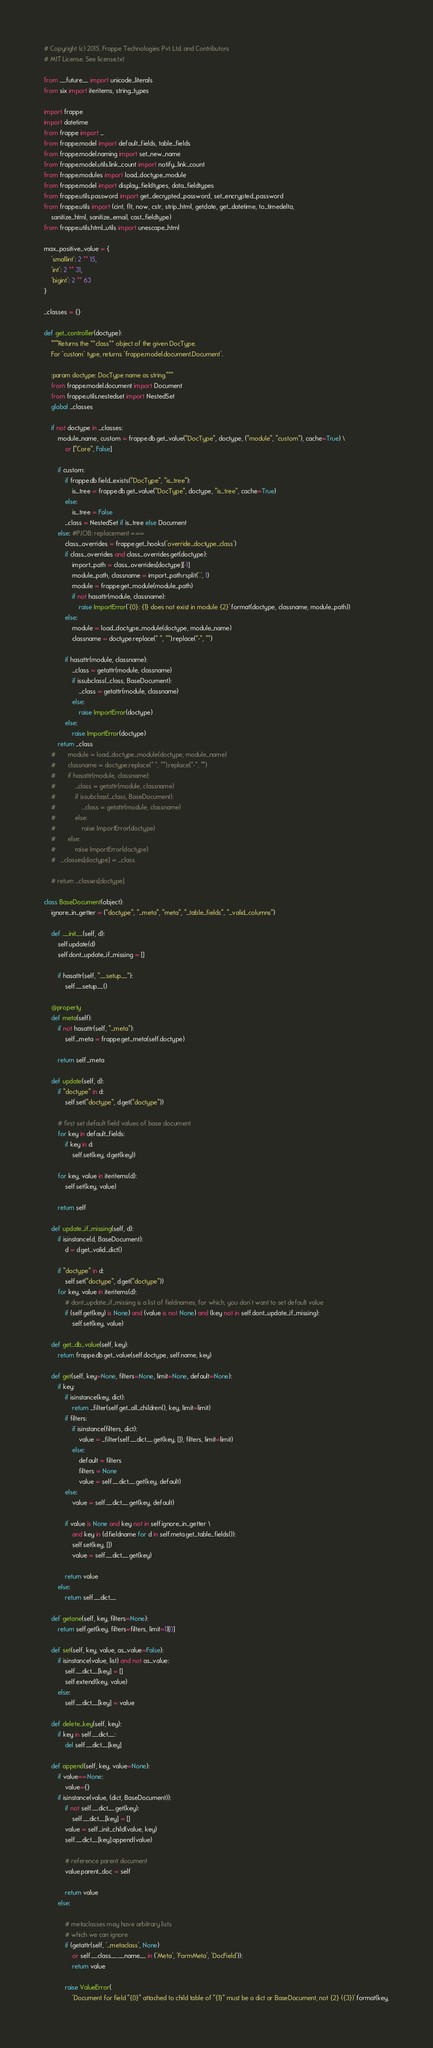<code> <loc_0><loc_0><loc_500><loc_500><_Python_># Copyright (c) 2015, Frappe Technologies Pvt. Ltd. and Contributors
# MIT License. See license.txt

from __future__ import unicode_literals
from six import iteritems, string_types

import frappe
import datetime
from frappe import _
from frappe.model import default_fields, table_fields
from frappe.model.naming import set_new_name
from frappe.model.utils.link_count import notify_link_count
from frappe.modules import load_doctype_module
from frappe.model import display_fieldtypes, data_fieldtypes
from frappe.utils.password import get_decrypted_password, set_encrypted_password
from frappe.utils import (cint, flt, now, cstr, strip_html, getdate, get_datetime, to_timedelta,
	sanitize_html, sanitize_email, cast_fieldtype)
from frappe.utils.html_utils import unescape_html

max_positive_value = {
	'smallint': 2 ** 15,
	'int': 2 ** 31,
	'bigint': 2 ** 63
}

_classes = {}

def get_controller(doctype):
	"""Returns the **class** object of the given DocType.
	For `custom` type, returns `frappe.model.document.Document`.

	:param doctype: DocType name as string."""
	from frappe.model.document import Document
	from frappe.utils.nestedset import NestedSet
	global _classes

	if not doctype in _classes:
		module_name, custom = frappe.db.get_value("DocType", doctype, ("module", "custom"), cache=True) \
			or ["Core", False]

		if custom:
			if frappe.db.field_exists("DocType", "is_tree"):
				is_tree = frappe.db.get_value("DocType", doctype, "is_tree", cache=True)
			else:
				is_tree = False
			_class = NestedSet if is_tree else Document
		else: #PJOB: replacement ===
			class_overrides = frappe.get_hooks('override_doctype_class')
			if class_overrides and class_overrides.get(doctype):
				import_path = class_overrides[doctype][-1]
				module_path, classname = import_path.rsplit('.', 1)
				module = frappe.get_module(module_path)
				if not hasattr(module, classname):
					raise ImportError('{0}: {1} does not exist in module {2}'.format(doctype, classname, module_path))
			else:
				module = load_doctype_module(doctype, module_name)
				classname = doctype.replace(" ", "").replace("-", "")

			if hasattr(module, classname):
				_class = getattr(module, classname)
				if issubclass(_class, BaseDocument):
					_class = getattr(module, classname)
				else:
					raise ImportError(doctype)
			else:
				raise ImportError(doctype)
		return _class
	# 		module = load_doctype_module(doctype, module_name)
	# 		classname = doctype.replace(" ", "").replace("-", "")
	# 		if hasattr(module, classname):
	# 			_class = getattr(module, classname)
	# 			if issubclass(_class, BaseDocument):
	# 				_class = getattr(module, classname)
	# 			else:
	# 				raise ImportError(doctype)
	# 		else:
	# 			raise ImportError(doctype)
	# 	_classes[doctype] = _class

	# return _classes[doctype]

class BaseDocument(object):
	ignore_in_getter = ("doctype", "_meta", "meta", "_table_fields", "_valid_columns")

	def __init__(self, d):
		self.update(d)
		self.dont_update_if_missing = []

		if hasattr(self, "__setup__"):
			self.__setup__()

	@property
	def meta(self):
		if not hasattr(self, "_meta"):
			self._meta = frappe.get_meta(self.doctype)

		return self._meta

	def update(self, d):
		if "doctype" in d:
			self.set("doctype", d.get("doctype"))

		# first set default field values of base document
		for key in default_fields:
			if key in d:
				self.set(key, d.get(key))

		for key, value in iteritems(d):
			self.set(key, value)

		return self

	def update_if_missing(self, d):
		if isinstance(d, BaseDocument):
			d = d.get_valid_dict()

		if "doctype" in d:
			self.set("doctype", d.get("doctype"))
		for key, value in iteritems(d):
			# dont_update_if_missing is a list of fieldnames, for which, you don't want to set default value
			if (self.get(key) is None) and (value is not None) and (key not in self.dont_update_if_missing):
				self.set(key, value)

	def get_db_value(self, key):
		return frappe.db.get_value(self.doctype, self.name, key)

	def get(self, key=None, filters=None, limit=None, default=None):
		if key:
			if isinstance(key, dict):
				return _filter(self.get_all_children(), key, limit=limit)
			if filters:
				if isinstance(filters, dict):
					value = _filter(self.__dict__.get(key, []), filters, limit=limit)
				else:
					default = filters
					filters = None
					value = self.__dict__.get(key, default)
			else:
				value = self.__dict__.get(key, default)

			if value is None and key not in self.ignore_in_getter \
				and key in (d.fieldname for d in self.meta.get_table_fields()):
				self.set(key, [])
				value = self.__dict__.get(key)

			return value
		else:
			return self.__dict__

	def getone(self, key, filters=None):
		return self.get(key, filters=filters, limit=1)[0]

	def set(self, key, value, as_value=False):
		if isinstance(value, list) and not as_value:
			self.__dict__[key] = []
			self.extend(key, value)
		else:
			self.__dict__[key] = value

	def delete_key(self, key):
		if key in self.__dict__:
			del self.__dict__[key]

	def append(self, key, value=None):
		if value==None:
			value={}
		if isinstance(value, (dict, BaseDocument)):
			if not self.__dict__.get(key):
				self.__dict__[key] = []
			value = self._init_child(value, key)
			self.__dict__[key].append(value)

			# reference parent document
			value.parent_doc = self

			return value
		else:

			# metaclasses may have arbitrary lists
			# which we can ignore
			if (getattr(self, '_metaclass', None)
				or self.__class__.__name__ in ('Meta', 'FormMeta', 'DocField')):
				return value

			raise ValueError(
				'Document for field "{0}" attached to child table of "{1}" must be a dict or BaseDocument, not {2} ({3})'.format(key,</code> 